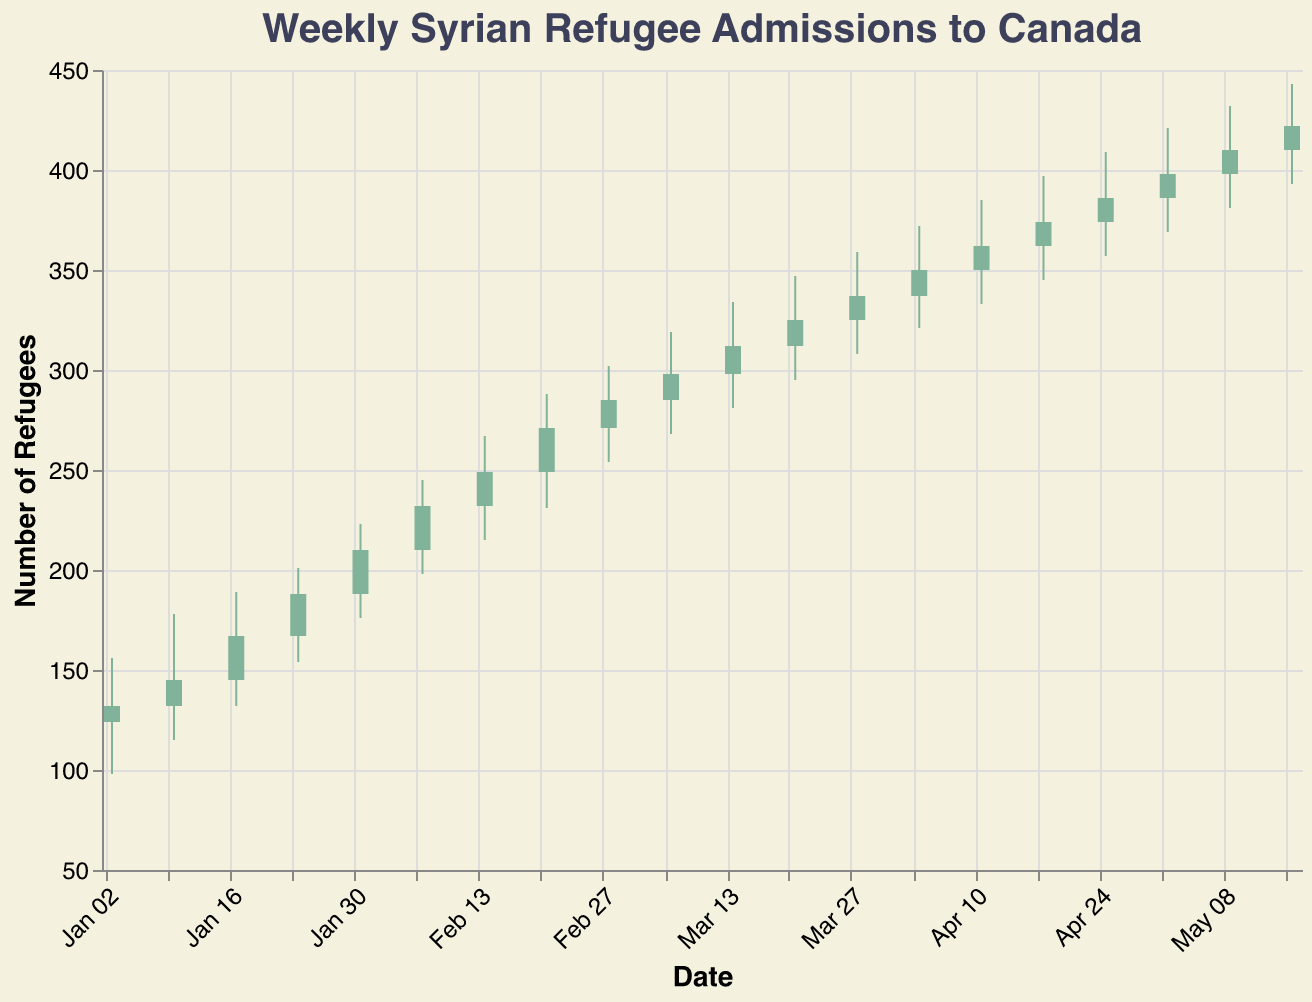What does the title of the chart say? The chart’s title is prominently located at the top and serves to explain the subject of the data being visualized. The title reads, "Weekly Syrian Refugee Admissions to Canada," which indicates that the chart presents the number of Syrian refugees admitted to Canada on a weekly basis over a year.
Answer: "Weekly Syrian Refugee Admissions to Canada" What is the color condition indicating in the chart? The color condition differentiates between weeks where the closing value is higher than the opening value. When the number of refugee admissions closes higher than it opened, the bar is green; otherwise, it is red.
Answer: Green bars indicate an increase from open to close; red bars indicate a decrease How many weeks have green bars? Green bars signify that the closing value for the week is higher than the opening value. By counting the number of such bars, we can determine the exact weeks associated with this trend.
Answer: 20 weeks In which week was the highest number of refugee admissions recorded? The highest number of refugee admissions is found by locating the highest "High" value on the chart. The week corresponding to this value has the highest number of admissions. According to the data, this occurs in the week of 2022-05-16 with a High of 443.
Answer: 2022-05-16 Which week experienced the largest weekly range of refugee admissions? The weekly range is calculated by subtracting the low value from the high value for each week. The week with the largest difference between high and low had the most fluctuations. By examining the data, 2022-05-16 had a range of 50 (443 - 393).
Answer: 2022-05-16 What was the closing number of refugee admissions on 2022-01-10? The closing number can be directly observed by identifying the value on the chart for the week of 2022-01-10. The closing value for this week is 145.
Answer: 145 Between which two consecutive weeks was the growth in the number of admissions the highest? To find the highest growth, compare the closing values of consecutive weeks and see which pair had the highest increase. For instance, from 2022-01-17 to 2022-01-24, there was a growth from 167 to 188, which is an increase of 21. By comparing all weeks, this period has the highest growth.
Answer: From 2022-01-17 to 2022-01-24 What is the average closing number of refugee admissions over the first five weeks? To find the average, sum up the closing values of the first five weeks: 132 (2022-01-03) + 145 (2022-01-10) + 167 (2022-01-17) + 188 (2022-01-24) + 210 (2022-01-31) = 842. Then, divide by the number of weeks (5).
Answer: 168.4 What was the trend in the number of refugee admissions in the first quarter (January to March) of the year? The trend is identified by looking at the change from the first week of January to the last week of March. In January, the closing values start at 132 and go up each week, ending in March at 337, indicating a steady increase in admissions.
Answer: Increasing trend What are the minimum and maximum number of refugee admissions in February? To find the minimum (Low) and maximum (High) values specifically in February, look at the weeks within this month: 2022-02-07 to 2022-02-28. The lowest value is 198 and the highest is 319. Thus, minimum is 198, and maximum is 319.
Answer: Minimum: 198, Maximum: 319 